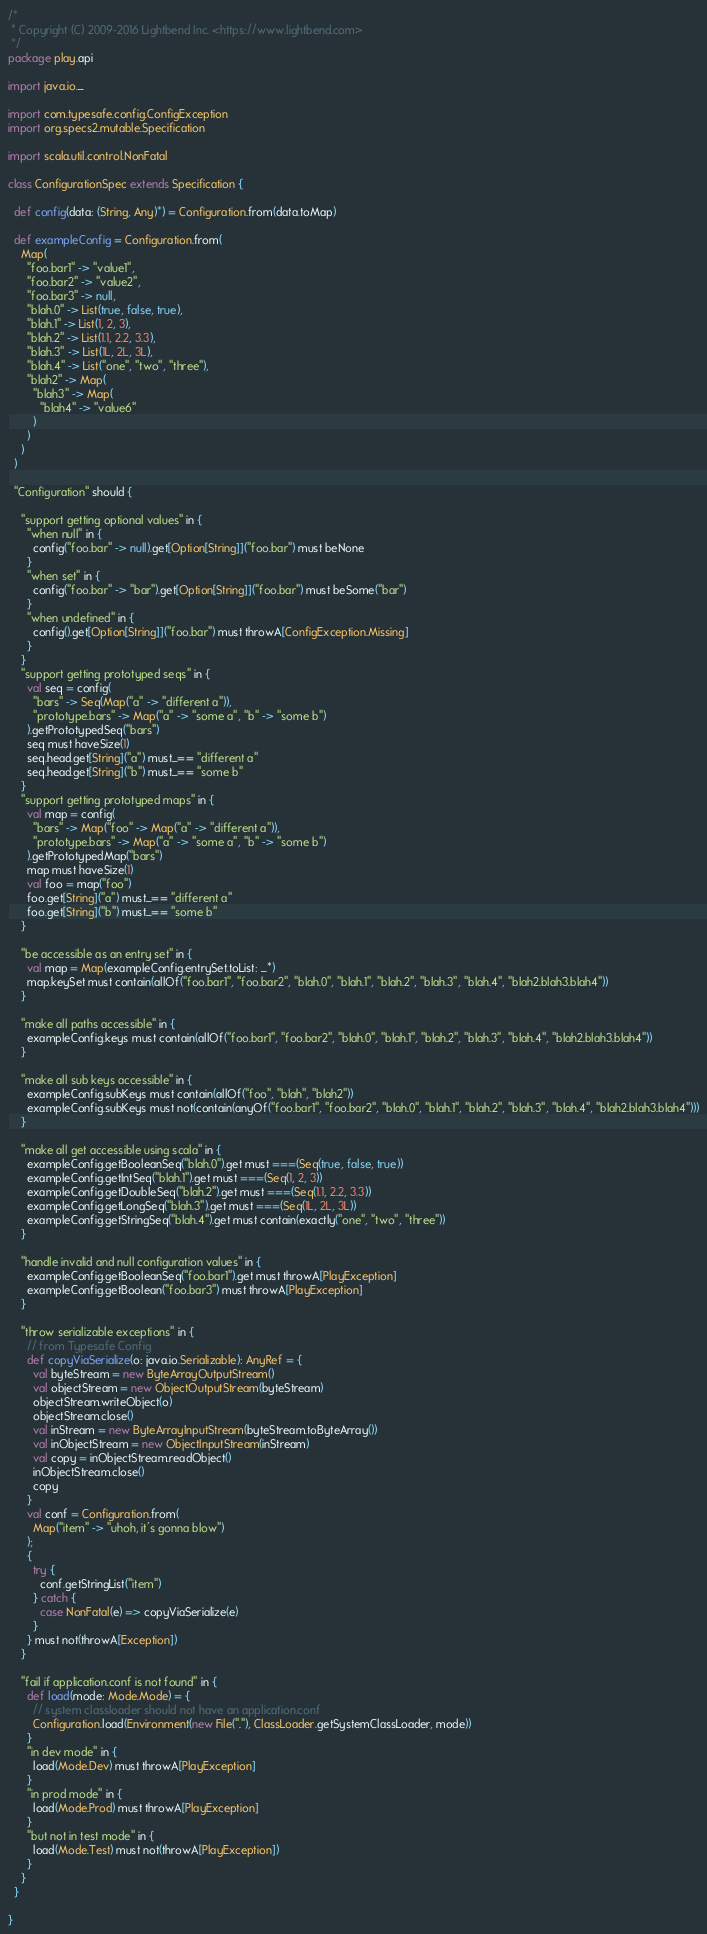Convert code to text. <code><loc_0><loc_0><loc_500><loc_500><_Scala_>/*
 * Copyright (C) 2009-2016 Lightbend Inc. <https://www.lightbend.com>
 */
package play.api

import java.io._

import com.typesafe.config.ConfigException
import org.specs2.mutable.Specification

import scala.util.control.NonFatal

class ConfigurationSpec extends Specification {

  def config(data: (String, Any)*) = Configuration.from(data.toMap)

  def exampleConfig = Configuration.from(
    Map(
      "foo.bar1" -> "value1",
      "foo.bar2" -> "value2",
      "foo.bar3" -> null,
      "blah.0" -> List(true, false, true),
      "blah.1" -> List(1, 2, 3),
      "blah.2" -> List(1.1, 2.2, 3.3),
      "blah.3" -> List(1L, 2L, 3L),
      "blah.4" -> List("one", "two", "three"),
      "blah2" -> Map(
        "blah3" -> Map(
          "blah4" -> "value6"
        )
      )
    )
  )

  "Configuration" should {

    "support getting optional values" in {
      "when null" in {
        config("foo.bar" -> null).get[Option[String]]("foo.bar") must beNone
      }
      "when set" in {
        config("foo.bar" -> "bar").get[Option[String]]("foo.bar") must beSome("bar")
      }
      "when undefined" in {
        config().get[Option[String]]("foo.bar") must throwA[ConfigException.Missing]
      }
    }
    "support getting prototyped seqs" in {
      val seq = config(
        "bars" -> Seq(Map("a" -> "different a")),
        "prototype.bars" -> Map("a" -> "some a", "b" -> "some b")
      ).getPrototypedSeq("bars")
      seq must haveSize(1)
      seq.head.get[String]("a") must_== "different a"
      seq.head.get[String]("b") must_== "some b"
    }
    "support getting prototyped maps" in {
      val map = config(
        "bars" -> Map("foo" -> Map("a" -> "different a")),
        "prototype.bars" -> Map("a" -> "some a", "b" -> "some b")
      ).getPrototypedMap("bars")
      map must haveSize(1)
      val foo = map("foo")
      foo.get[String]("a") must_== "different a"
      foo.get[String]("b") must_== "some b"
    }

    "be accessible as an entry set" in {
      val map = Map(exampleConfig.entrySet.toList: _*)
      map.keySet must contain(allOf("foo.bar1", "foo.bar2", "blah.0", "blah.1", "blah.2", "blah.3", "blah.4", "blah2.blah3.blah4"))
    }

    "make all paths accessible" in {
      exampleConfig.keys must contain(allOf("foo.bar1", "foo.bar2", "blah.0", "blah.1", "blah.2", "blah.3", "blah.4", "blah2.blah3.blah4"))
    }

    "make all sub keys accessible" in {
      exampleConfig.subKeys must contain(allOf("foo", "blah", "blah2"))
      exampleConfig.subKeys must not(contain(anyOf("foo.bar1", "foo.bar2", "blah.0", "blah.1", "blah.2", "blah.3", "blah.4", "blah2.blah3.blah4")))
    }

    "make all get accessible using scala" in {
      exampleConfig.getBooleanSeq("blah.0").get must ===(Seq(true, false, true))
      exampleConfig.getIntSeq("blah.1").get must ===(Seq(1, 2, 3))
      exampleConfig.getDoubleSeq("blah.2").get must ===(Seq(1.1, 2.2, 3.3))
      exampleConfig.getLongSeq("blah.3").get must ===(Seq(1L, 2L, 3L))
      exampleConfig.getStringSeq("blah.4").get must contain(exactly("one", "two", "three"))
    }

    "handle invalid and null configuration values" in {
      exampleConfig.getBooleanSeq("foo.bar1").get must throwA[PlayException]
      exampleConfig.getBoolean("foo.bar3") must throwA[PlayException]
    }

    "throw serializable exceptions" in {
      // from Typesafe Config
      def copyViaSerialize(o: java.io.Serializable): AnyRef = {
        val byteStream = new ByteArrayOutputStream()
        val objectStream = new ObjectOutputStream(byteStream)
        objectStream.writeObject(o)
        objectStream.close()
        val inStream = new ByteArrayInputStream(byteStream.toByteArray())
        val inObjectStream = new ObjectInputStream(inStream)
        val copy = inObjectStream.readObject()
        inObjectStream.close()
        copy
      }
      val conf = Configuration.from(
        Map("item" -> "uhoh, it's gonna blow")
      );
      {
        try {
          conf.getStringList("item")
        } catch {
          case NonFatal(e) => copyViaSerialize(e)
        }
      } must not(throwA[Exception])
    }

    "fail if application.conf is not found" in {
      def load(mode: Mode.Mode) = {
        // system classloader should not have an application.conf
        Configuration.load(Environment(new File("."), ClassLoader.getSystemClassLoader, mode))
      }
      "in dev mode" in {
        load(Mode.Dev) must throwA[PlayException]
      }
      "in prod mode" in {
        load(Mode.Prod) must throwA[PlayException]
      }
      "but not in test mode" in {
        load(Mode.Test) must not(throwA[PlayException])
      }
    }
  }

}
</code> 